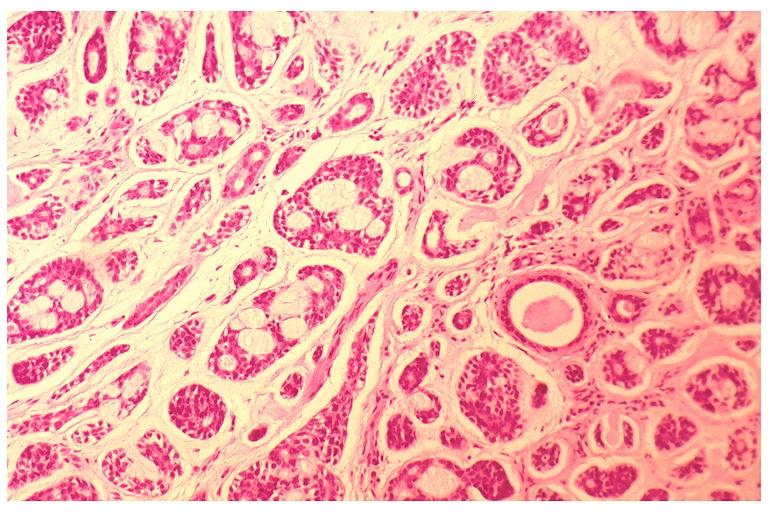does this image show adenoid cystic carcinoma?
Answer the question using a single word or phrase. Yes 